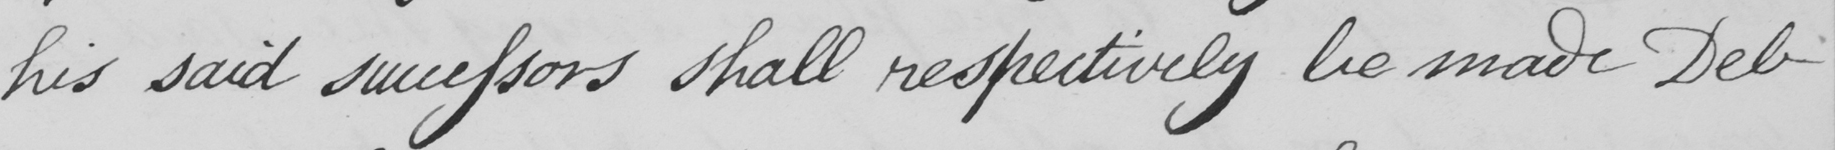Can you read and transcribe this handwriting? his said successors shall respectively be made Deb- 